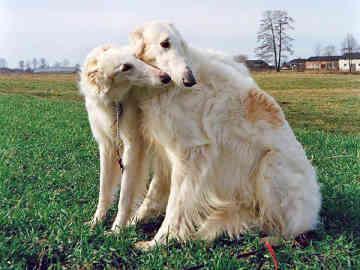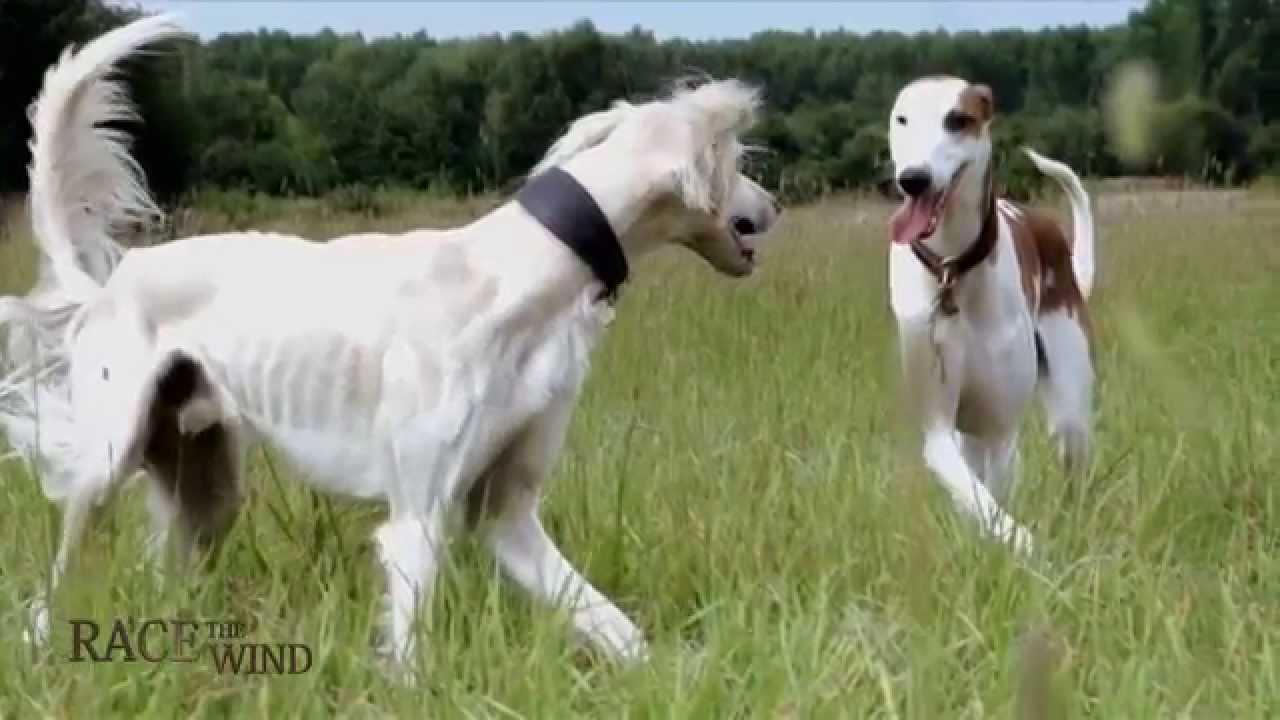The first image is the image on the left, the second image is the image on the right. Assess this claim about the two images: "At least three people, including one in bright red, stand in a row behind dogs standing on grass.". Correct or not? Answer yes or no. No. 